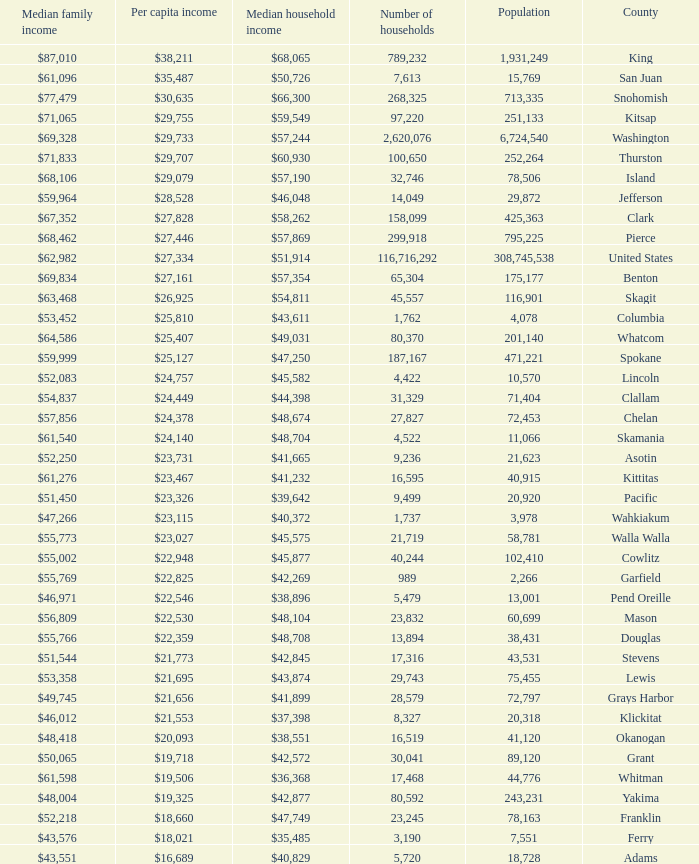How much is per capita income when median household income is $42,845? $21,773. 